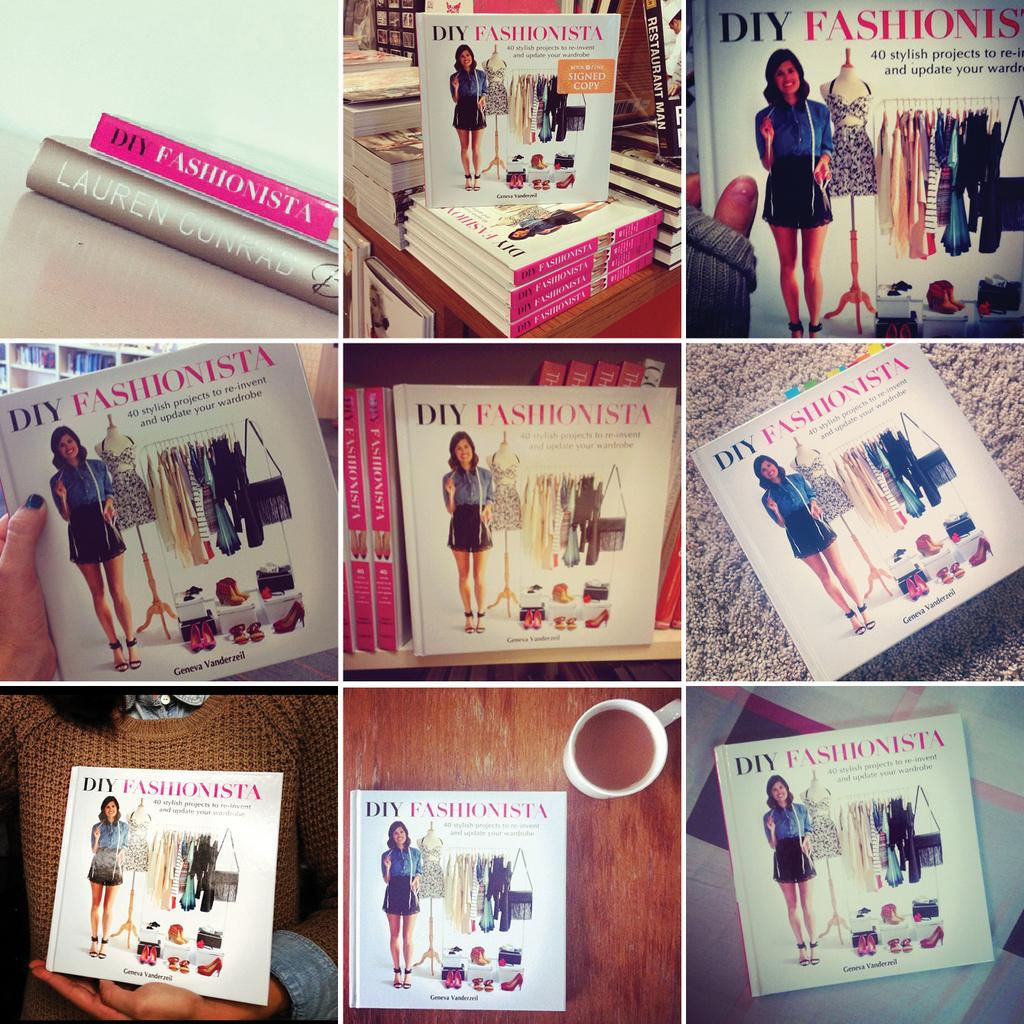<image>
Offer a succinct explanation of the picture presented. A collection of images of books titled DIY Fashionista. 